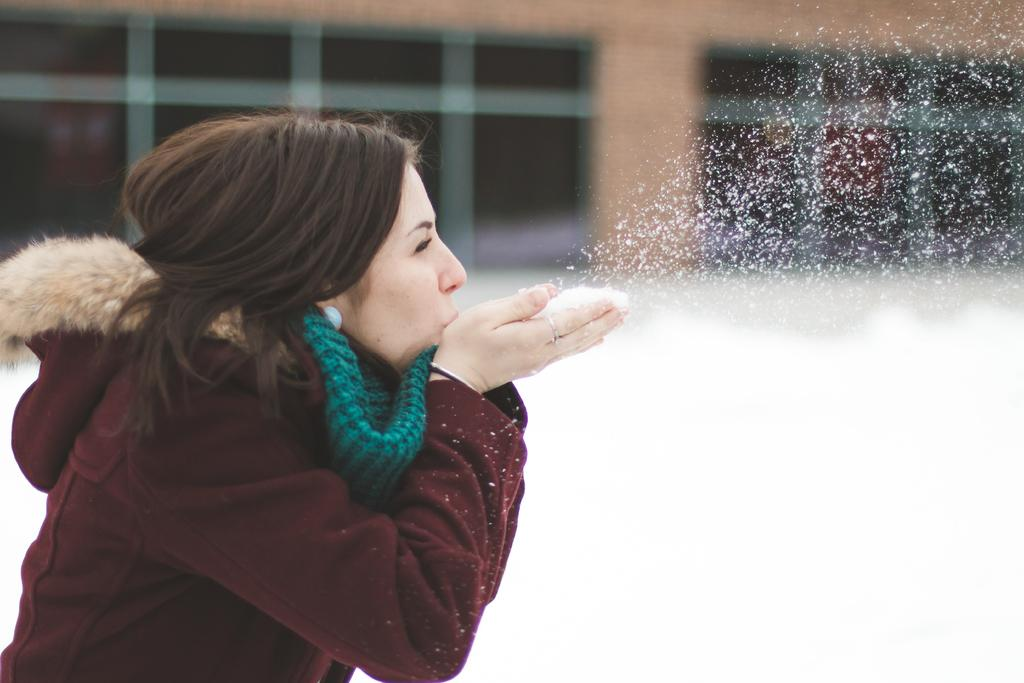Who is the main subject in the image? There is a woman in the image. What is the woman doing in the image? The woman is blowing snow. What can be seen in the background of the image? There is a building in the background of the image. What is the condition of the surface in the image? Snow is present on the surface in the image. What type of ink is the woman using to write in the snow? There is no ink present in the image, as the woman is blowing snow rather than writing with it. 